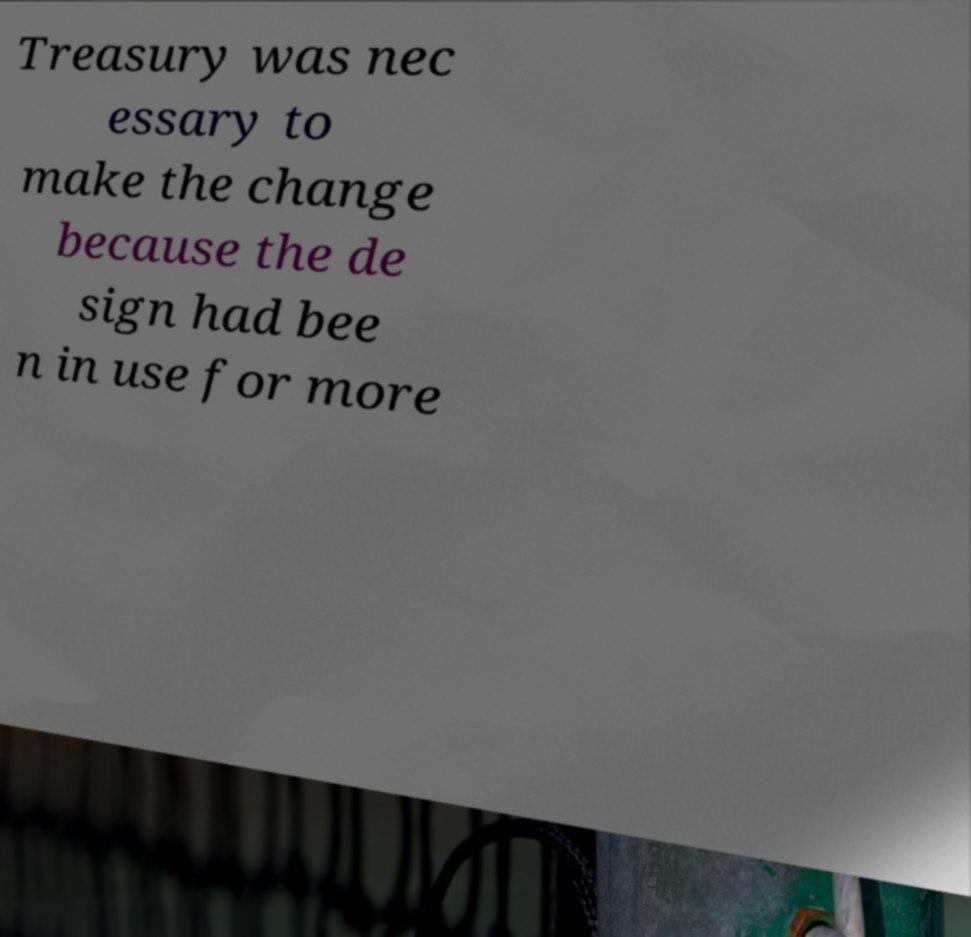Can you accurately transcribe the text from the provided image for me? Treasury was nec essary to make the change because the de sign had bee n in use for more 